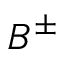Convert formula to latex. <formula><loc_0><loc_0><loc_500><loc_500>B ^ { \pm }</formula> 